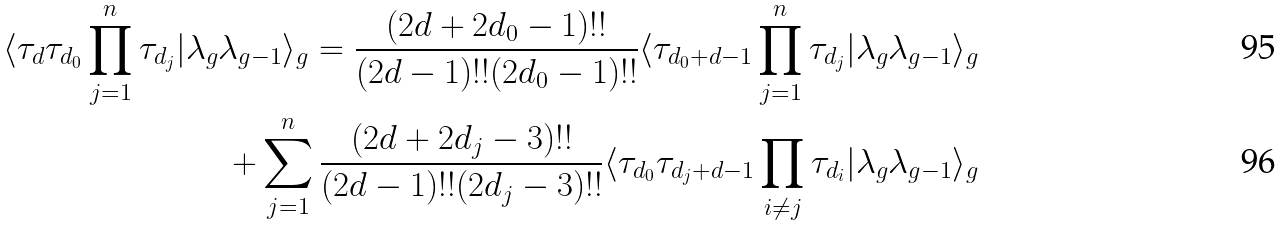<formula> <loc_0><loc_0><loc_500><loc_500>\langle \tau _ { d } \tau _ { d _ { 0 } } \prod _ { j = 1 } ^ { n } \tau _ { d _ { j } } | \lambda _ { g } \lambda _ { g - 1 } \rangle _ { g } = \frac { ( 2 d + 2 d _ { 0 } - 1 ) ! ! } { ( 2 d - 1 ) ! ! ( 2 d _ { 0 } - 1 ) ! ! } \langle \tau _ { d _ { 0 } + d - 1 } \prod _ { j = 1 } ^ { n } \tau _ { d _ { j } } | \lambda _ { g } \lambda _ { g - 1 } \rangle _ { g } \\ + \sum _ { j = 1 } ^ { n } \frac { ( 2 d + 2 d _ { j } - 3 ) ! ! } { ( 2 d - 1 ) ! ! ( 2 d _ { j } - 3 ) ! ! } \langle \tau _ { d _ { 0 } } \tau _ { d _ { j } + d - 1 } \prod _ { i \neq j } \tau _ { d _ { i } } | \lambda _ { g } \lambda _ { g - 1 } \rangle _ { g }</formula> 